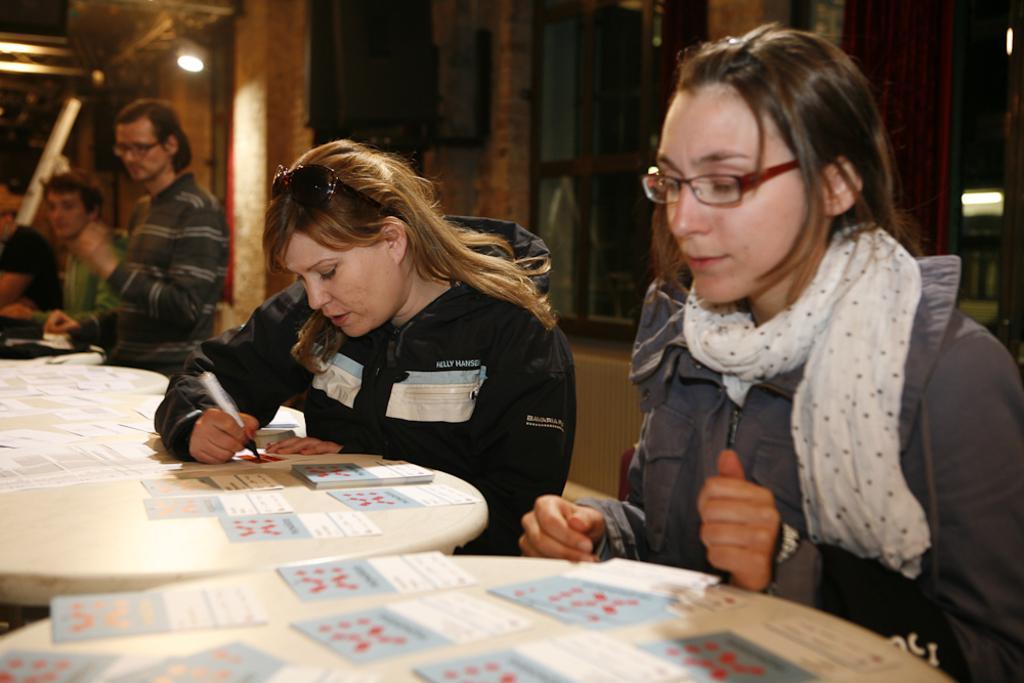How would you summarize this image in a sentence or two? In this picture there is a woman sitting and writing and there is a woman sitting. At the back there are group of people. There are cards and papers on the table. At the back there are windows. At the top there are lights. 